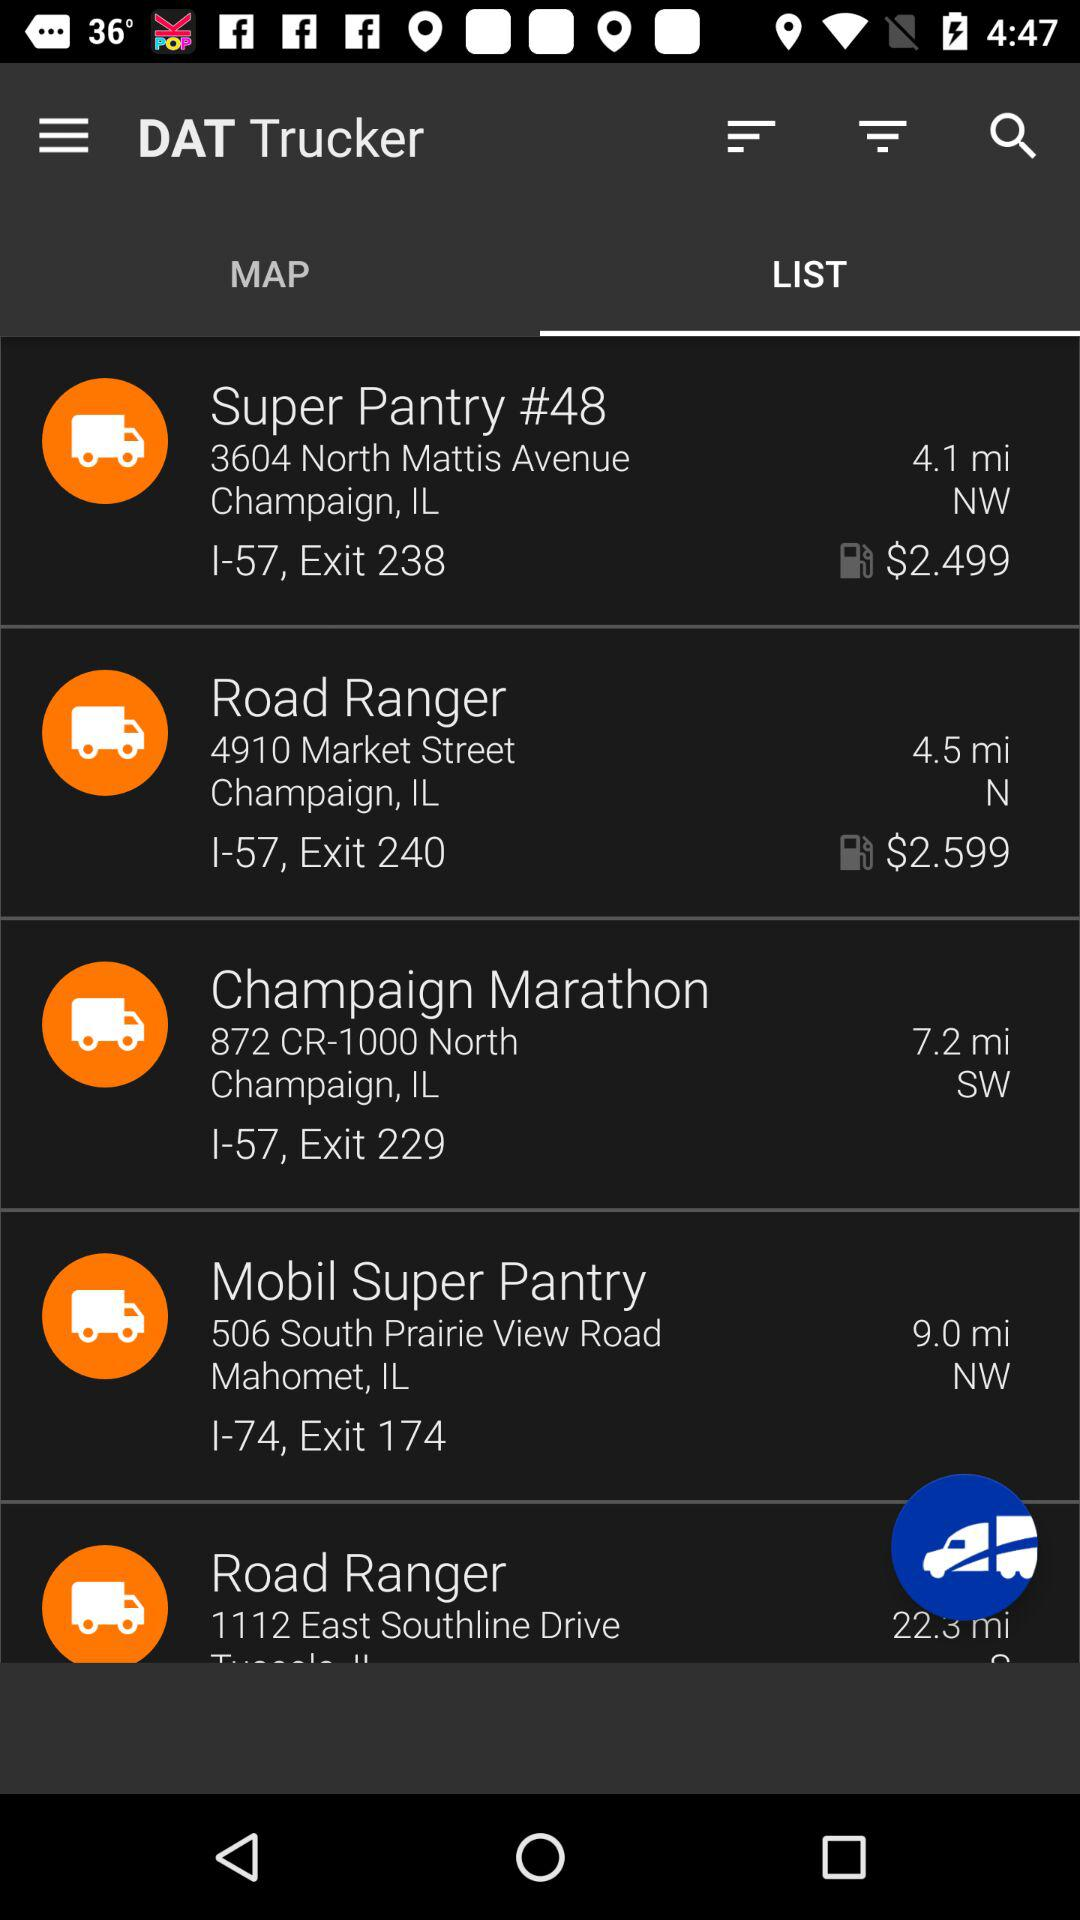What is the fuel price showing for the "Road Ranger"? The fuel price is $2.599. 